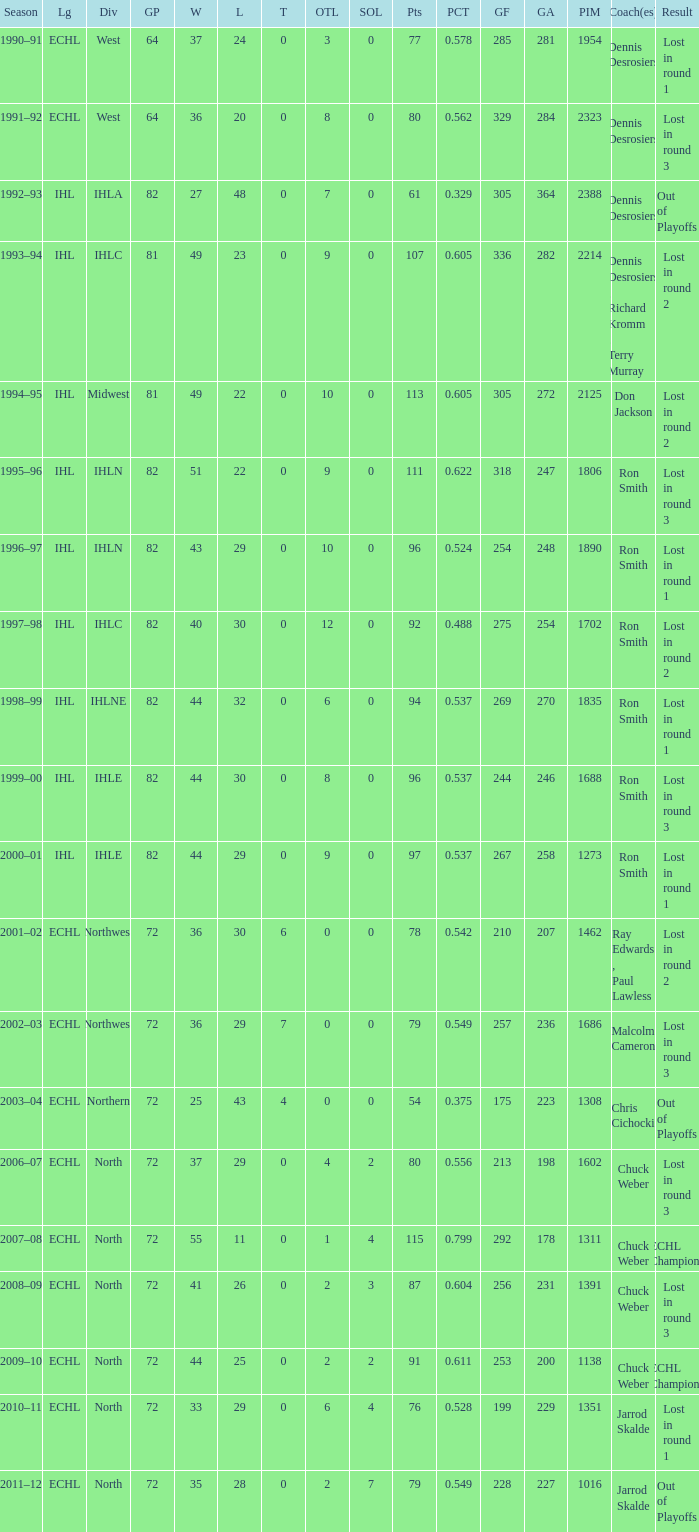In round 3, what was the highest score of loss (sol) experienced by the team? 3.0. 